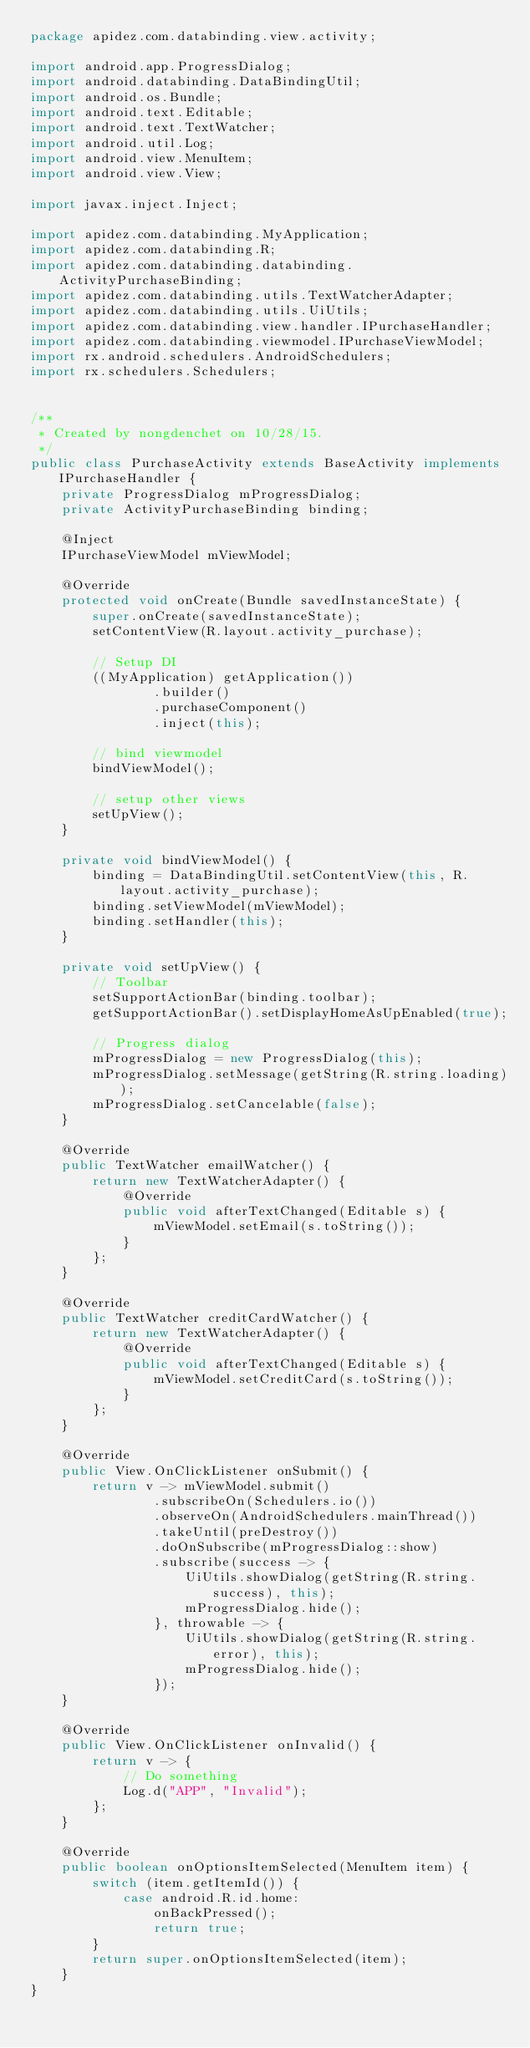Convert code to text. <code><loc_0><loc_0><loc_500><loc_500><_Java_>package apidez.com.databinding.view.activity;

import android.app.ProgressDialog;
import android.databinding.DataBindingUtil;
import android.os.Bundle;
import android.text.Editable;
import android.text.TextWatcher;
import android.util.Log;
import android.view.MenuItem;
import android.view.View;

import javax.inject.Inject;

import apidez.com.databinding.MyApplication;
import apidez.com.databinding.R;
import apidez.com.databinding.databinding.ActivityPurchaseBinding;
import apidez.com.databinding.utils.TextWatcherAdapter;
import apidez.com.databinding.utils.UiUtils;
import apidez.com.databinding.view.handler.IPurchaseHandler;
import apidez.com.databinding.viewmodel.IPurchaseViewModel;
import rx.android.schedulers.AndroidSchedulers;
import rx.schedulers.Schedulers;


/**
 * Created by nongdenchet on 10/28/15.
 */
public class PurchaseActivity extends BaseActivity implements IPurchaseHandler {
    private ProgressDialog mProgressDialog;
    private ActivityPurchaseBinding binding;

    @Inject
    IPurchaseViewModel mViewModel;

    @Override
    protected void onCreate(Bundle savedInstanceState) {
        super.onCreate(savedInstanceState);
        setContentView(R.layout.activity_purchase);

        // Setup DI
        ((MyApplication) getApplication())
                .builder()
                .purchaseComponent()
                .inject(this);

        // bind viewmodel
        bindViewModel();

        // setup other views
        setUpView();
    }

    private void bindViewModel() {
        binding = DataBindingUtil.setContentView(this, R.layout.activity_purchase);
        binding.setViewModel(mViewModel);
        binding.setHandler(this);
    }

    private void setUpView() {
        // Toolbar
        setSupportActionBar(binding.toolbar);
        getSupportActionBar().setDisplayHomeAsUpEnabled(true);

        // Progress dialog
        mProgressDialog = new ProgressDialog(this);
        mProgressDialog.setMessage(getString(R.string.loading));
        mProgressDialog.setCancelable(false);
    }

    @Override
    public TextWatcher emailWatcher() {
        return new TextWatcherAdapter() {
            @Override
            public void afterTextChanged(Editable s) {
                mViewModel.setEmail(s.toString());
            }
        };
    }

    @Override
    public TextWatcher creditCardWatcher() {
        return new TextWatcherAdapter() {
            @Override
            public void afterTextChanged(Editable s) {
                mViewModel.setCreditCard(s.toString());
            }
        };
    }

    @Override
    public View.OnClickListener onSubmit() {
        return v -> mViewModel.submit()
                .subscribeOn(Schedulers.io())
                .observeOn(AndroidSchedulers.mainThread())
                .takeUntil(preDestroy())
                .doOnSubscribe(mProgressDialog::show)
                .subscribe(success -> {
                    UiUtils.showDialog(getString(R.string.success), this);
                    mProgressDialog.hide();
                }, throwable -> {
                    UiUtils.showDialog(getString(R.string.error), this);
                    mProgressDialog.hide();
                });
    }

    @Override
    public View.OnClickListener onInvalid() {
        return v -> {
            // Do something
            Log.d("APP", "Invalid");
        };
    }

    @Override
    public boolean onOptionsItemSelected(MenuItem item) {
        switch (item.getItemId()) {
            case android.R.id.home:
                onBackPressed();
                return true;
        }
        return super.onOptionsItemSelected(item);
    }
}
</code> 